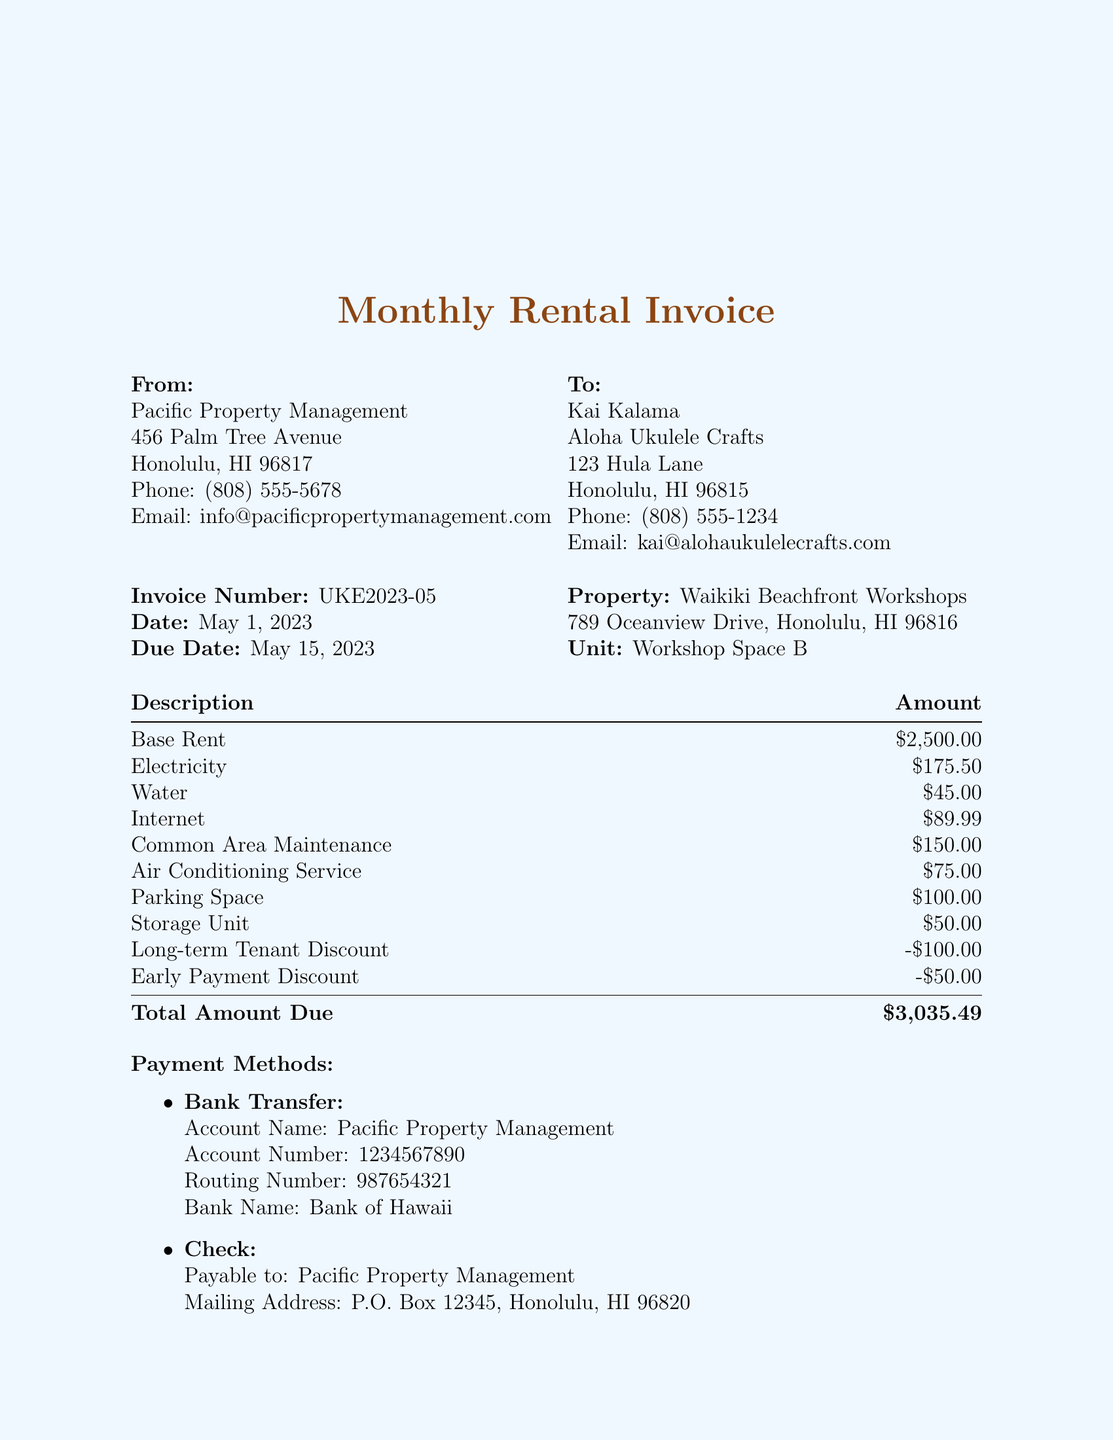What is the invoice number? The invoice number is specifically mentioned in the document under invoice details.
Answer: UKE2023-05 What is the total amount due? The total amount due is listed at the end of the rental charges section in the document.
Answer: $3,035.49 What is the business name of the craftsman? The business name of the craftsman is stated at the top of the document under craftsman details.
Answer: Aloha Ukulele Crafts What is the rental fee for the parking space? The parking space fee is detailed in the additional charges section of the invoice.
Answer: $100.00 What is the due date for the invoice? The due date is clearly indicated in the invoice details section of the document.
Answer: May 15, 2023 How much is the discount for early payment? The discount for early payment is listed under the discounts section of the invoice.
Answer: -$50.00 Who should checks be made payable to? The document specifies who checks should be made out to in the payment methods section.
Answer: Pacific Property Management What is the total base rent amount? The base rent amount is listed under the rental charges section of the invoice.
Answer: $2,500.00 Which organization manages the property? The landlord organization is identified in the landlord details section of the document.
Answer: Pacific Property Management 